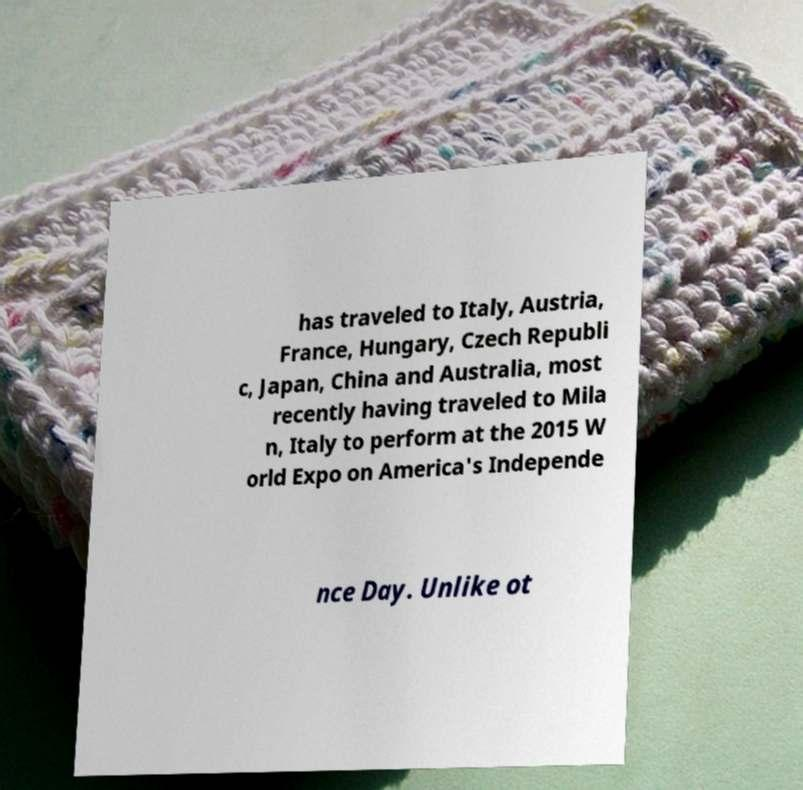Please read and relay the text visible in this image. What does it say? has traveled to Italy, Austria, France, Hungary, Czech Republi c, Japan, China and Australia, most recently having traveled to Mila n, Italy to perform at the 2015 W orld Expo on America's Independe nce Day. Unlike ot 